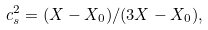Convert formula to latex. <formula><loc_0><loc_0><loc_500><loc_500>c _ { s } ^ { 2 } = ( X - X _ { 0 } ) / ( 3 X - X _ { 0 } ) ,</formula> 